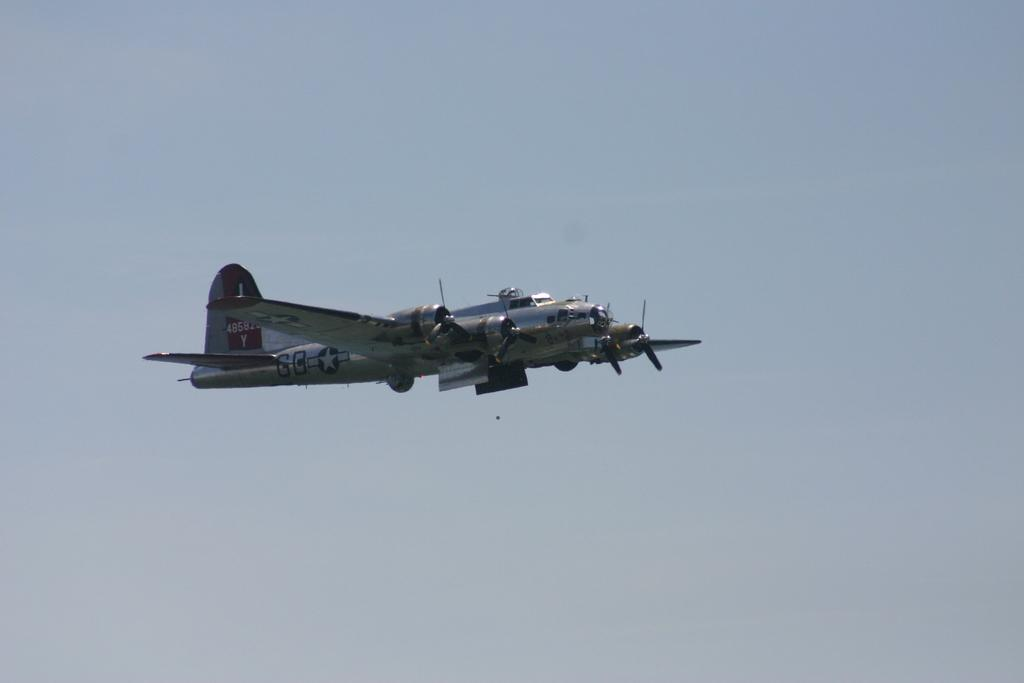<image>
Share a concise interpretation of the image provided. The letter Y is painted on the tail of a propeller plane. 